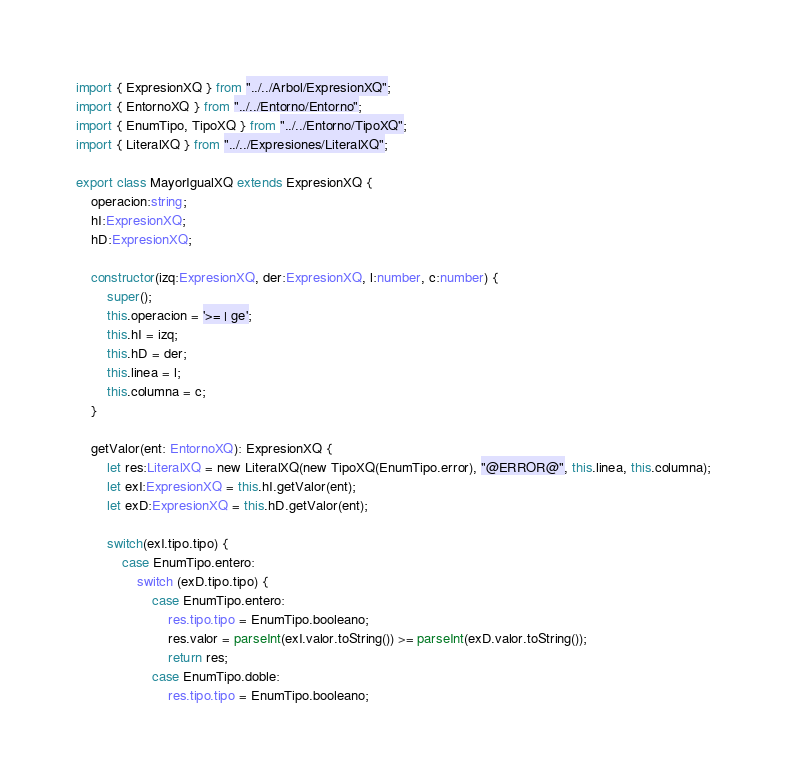<code> <loc_0><loc_0><loc_500><loc_500><_TypeScript_>import { ExpresionXQ } from "../../Arbol/ExpresionXQ";
import { EntornoXQ } from "../../Entorno/Entorno";
import { EnumTipo, TipoXQ } from "../../Entorno/TipoXQ";
import { LiteralXQ } from "../../Expresiones/LiteralXQ";

export class MayorIgualXQ extends ExpresionXQ {
    operacion:string;
    hI:ExpresionXQ;
    hD:ExpresionXQ;

    constructor(izq:ExpresionXQ, der:ExpresionXQ, l:number, c:number) {
        super();
        this.operacion = '>= | ge';
        this.hI = izq;
        this.hD = der;
        this.linea = l;
        this.columna = c;
    }
    
    getValor(ent: EntornoXQ): ExpresionXQ {
        let res:LiteralXQ = new LiteralXQ(new TipoXQ(EnumTipo.error), "@ERROR@", this.linea, this.columna);
        let exI:ExpresionXQ = this.hI.getValor(ent);
        let exD:ExpresionXQ = this.hD.getValor(ent);

        switch(exI.tipo.tipo) {
            case EnumTipo.entero:
                switch (exD.tipo.tipo) {
                    case EnumTipo.entero:
                        res.tipo.tipo = EnumTipo.booleano;
                        res.valor = parseInt(exI.valor.toString()) >= parseInt(exD.valor.toString());
                        return res;
                    case EnumTipo.doble:
                        res.tipo.tipo = EnumTipo.booleano;</code> 